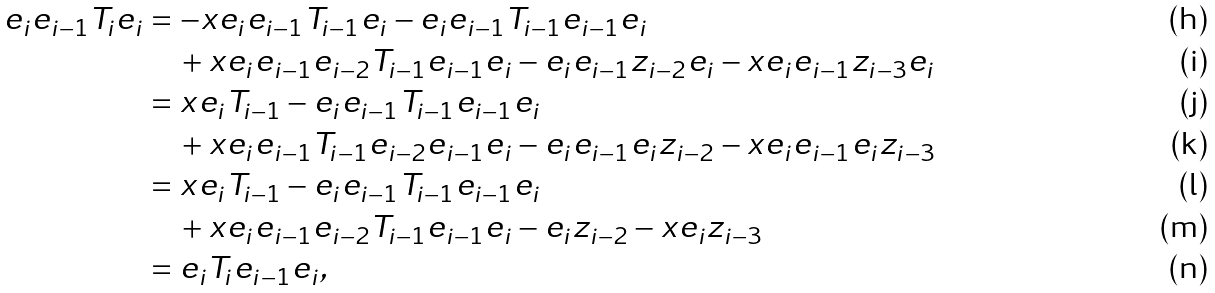Convert formula to latex. <formula><loc_0><loc_0><loc_500><loc_500>e _ { i } e _ { i - 1 } T _ { i } e _ { i } & = - x e _ { i } e _ { i - 1 } T _ { i - 1 } e _ { i } - e _ { i } e _ { i - 1 } T _ { i - 1 } e _ { i - 1 } e _ { i } \\ & \quad + x e _ { i } e _ { i - 1 } e _ { i - 2 } T _ { i - 1 } e _ { i - 1 } e _ { i } - e _ { i } e _ { i - 1 } z _ { i - 2 } e _ { i } - x e _ { i } e _ { i - 1 } z _ { i - 3 } e _ { i } \\ & = x e _ { i } T _ { i - 1 } - e _ { i } e _ { i - 1 } T _ { i - 1 } e _ { i - 1 } e _ { i } \\ & \quad + x e _ { i } e _ { i - 1 } T _ { i - 1 } e _ { i - 2 } e _ { i - 1 } e _ { i } - e _ { i } e _ { i - 1 } e _ { i } z _ { i - 2 } - x e _ { i } e _ { i - 1 } e _ { i } z _ { i - 3 } \\ & = x e _ { i } T _ { i - 1 } - e _ { i } e _ { i - 1 } T _ { i - 1 } e _ { i - 1 } e _ { i } \\ & \quad + x e _ { i } e _ { i - 1 } e _ { i - 2 } T _ { i - 1 } e _ { i - 1 } e _ { i } - e _ { i } z _ { i - 2 } - x e _ { i } z _ { i - 3 } \\ & = e _ { i } T _ { i } e _ { i - 1 } e _ { i } ,</formula> 